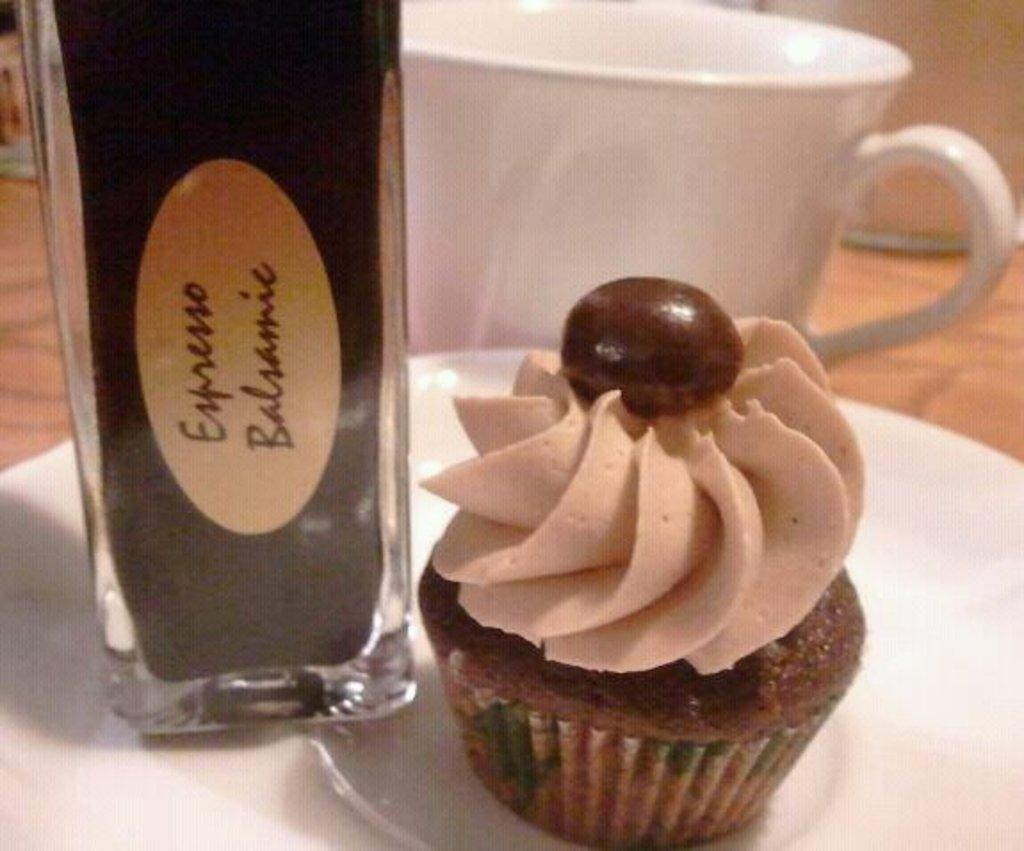<image>
Offer a succinct explanation of the picture presented. A bottle that says Expresso Balsamic next to a chocolate cupcake. 